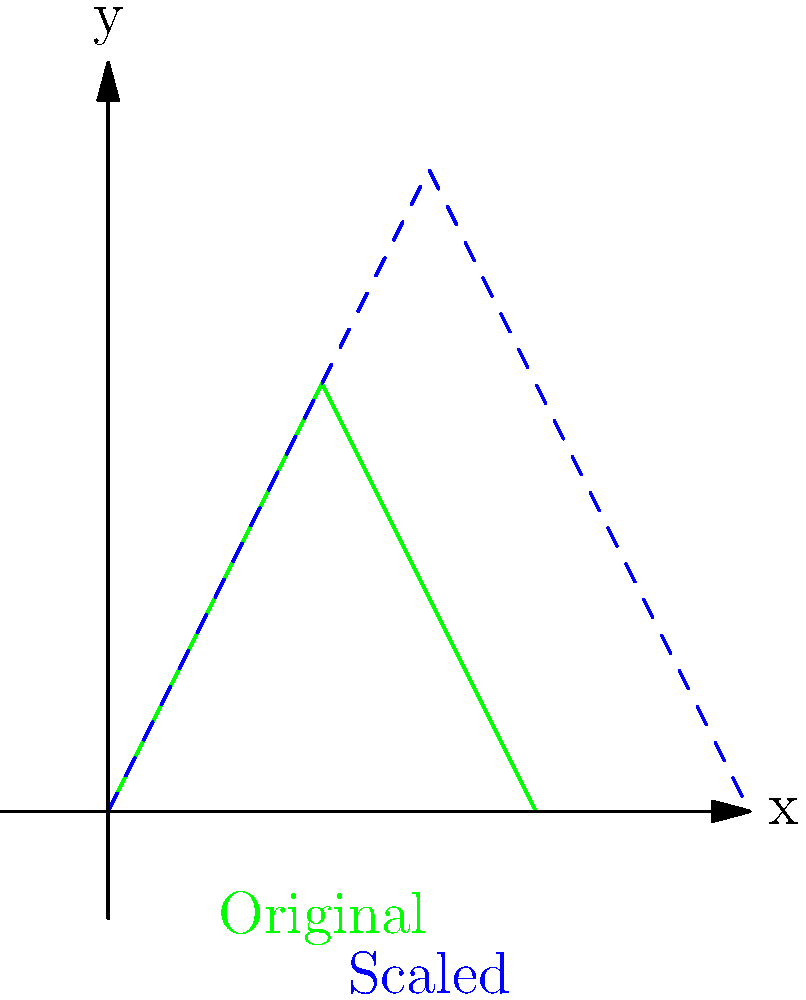As an environmental scientist studying forest density changes, you're analyzing tree silhouettes. If a tree's silhouette is scaled by a factor of 1.5 to represent increased forest density, what is the ratio of the area of the scaled silhouette to the original silhouette? To solve this problem, let's follow these steps:

1) In transformational geometry, when an object is scaled by a factor $k$ in both dimensions, its area is scaled by a factor of $k^2$.

2) In this case, the scaling factor is 1.5.

3) Therefore, the area scaling factor is:
   $$(1.5)^2 = 2.25$$

4) This means the area of the scaled silhouette is 2.25 times the area of the original silhouette.

5) The ratio of the scaled area to the original area is thus 2.25 : 1.

This scaling principle is crucial in environmental science for understanding how changes in individual tree sizes can affect overall forest density and canopy cover, which have significant implications for ecosystems and climate models.
Answer: 2.25 : 1 